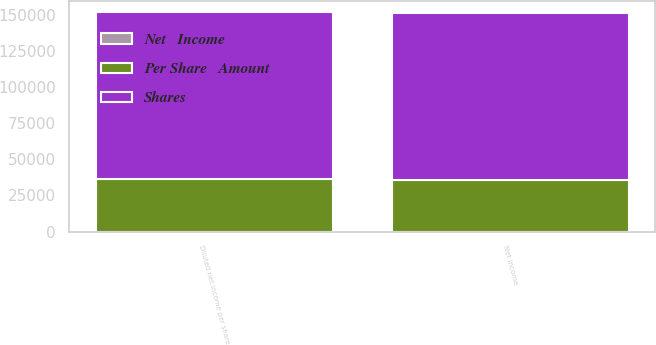<chart> <loc_0><loc_0><loc_500><loc_500><stacked_bar_chart><ecel><fcel>Net income<fcel>Diluted net income per share<nl><fcel>Shares<fcel>115466<fcel>115466<nl><fcel>Per Share   Amount<fcel>35990<fcel>36649<nl><fcel>Net   Income<fcel>3.21<fcel>3.15<nl></chart> 